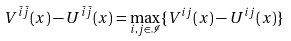<formula> <loc_0><loc_0><loc_500><loc_500>V ^ { \bar { i } \bar { j } } ( x ) - U ^ { \bar { i } \bar { j } } ( x ) = \max _ { i , j \in \mathcal { I } } \{ V ^ { i j } ( x ) - U ^ { i j } ( x ) \}</formula> 